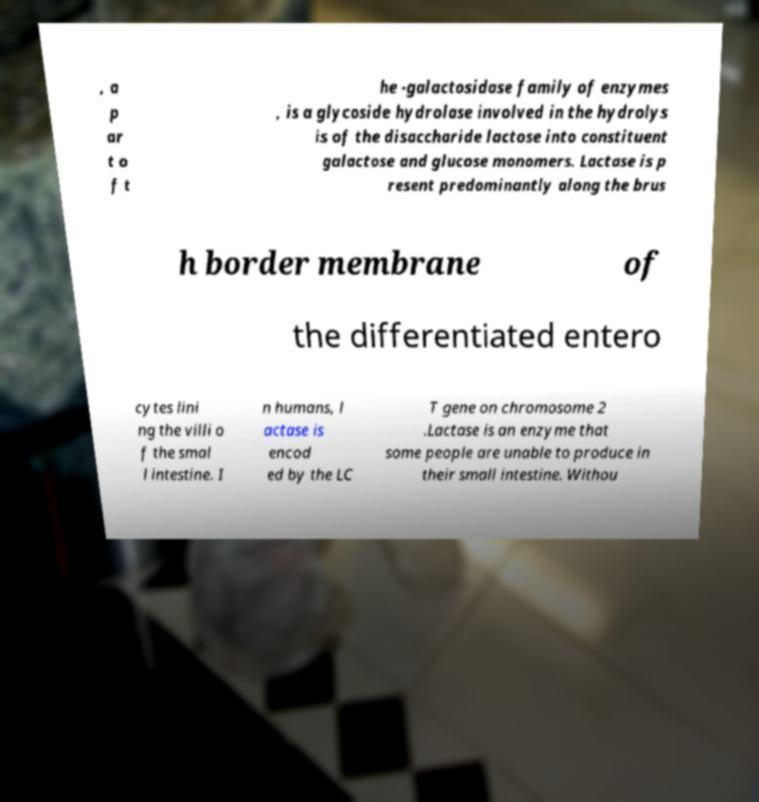Can you read and provide the text displayed in the image?This photo seems to have some interesting text. Can you extract and type it out for me? , a p ar t o f t he -galactosidase family of enzymes , is a glycoside hydrolase involved in the hydrolys is of the disaccharide lactose into constituent galactose and glucose monomers. Lactase is p resent predominantly along the brus h border membrane of the differentiated entero cytes lini ng the villi o f the smal l intestine. I n humans, l actase is encod ed by the LC T gene on chromosome 2 .Lactase is an enzyme that some people are unable to produce in their small intestine. Withou 